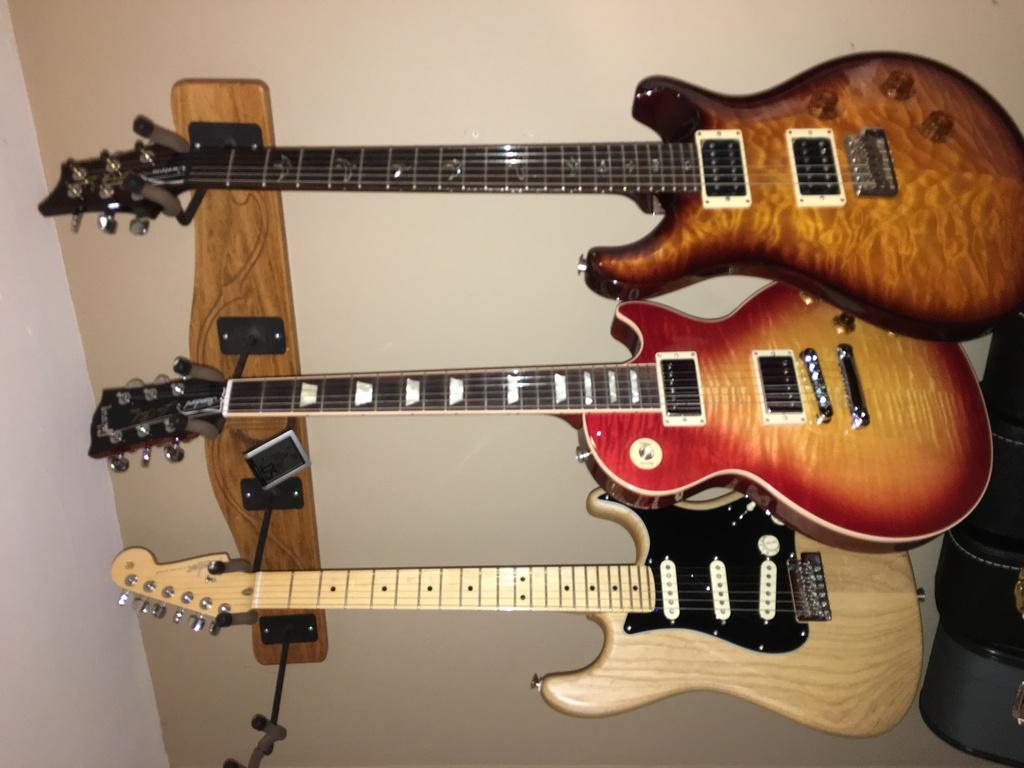What type of musical instruments are in the image? There are guitars in the image. How are the guitars positioned in the image? The guitars are hanging on a hanger. What type of soap is used to clean the guitars in the image? There is no soap present in the image, and the guitars are not being cleaned. What can be found in the pocket of the person holding the guitars in the image? There is no person holding the guitars in the image, and therefore no pocket to examine. 